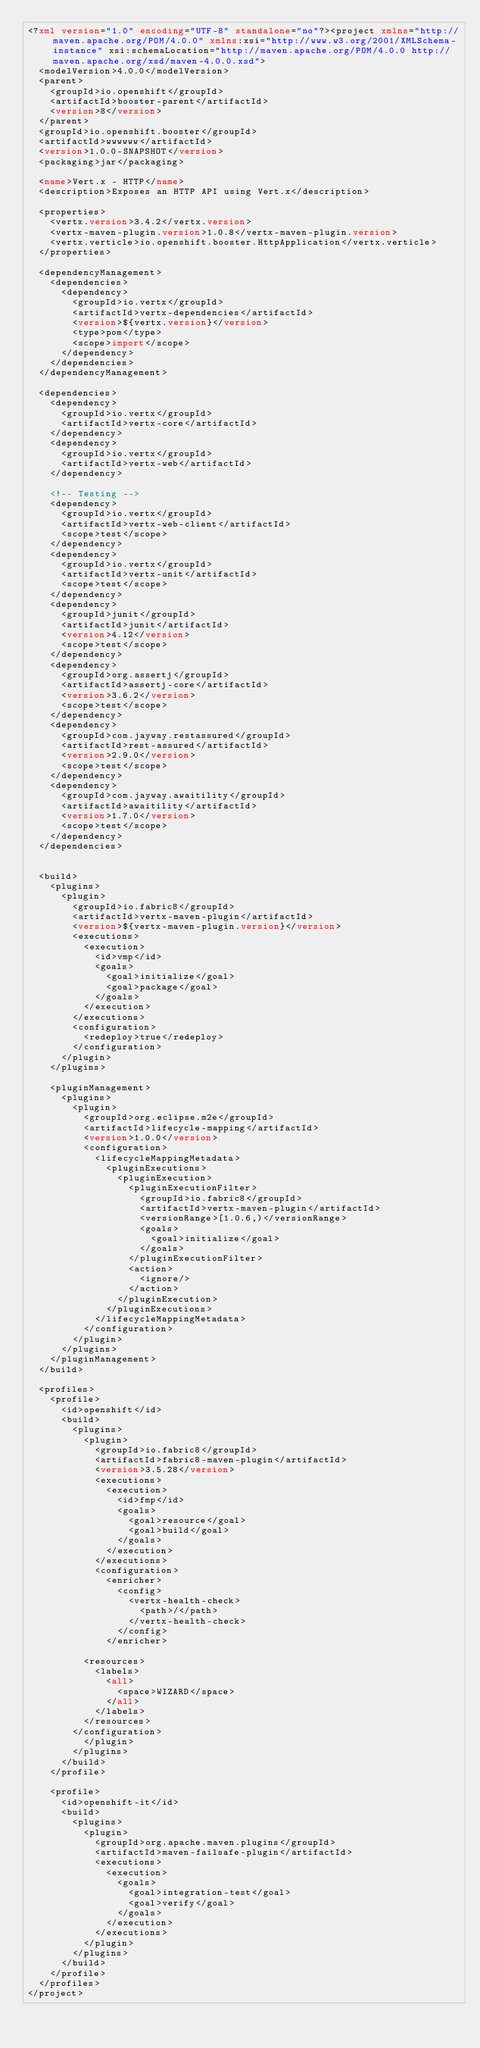Convert code to text. <code><loc_0><loc_0><loc_500><loc_500><_XML_><?xml version="1.0" encoding="UTF-8" standalone="no"?><project xmlns="http://maven.apache.org/POM/4.0.0" xmlns:xsi="http://www.w3.org/2001/XMLSchema-instance" xsi:schemaLocation="http://maven.apache.org/POM/4.0.0 http://maven.apache.org/xsd/maven-4.0.0.xsd">
  <modelVersion>4.0.0</modelVersion>
  <parent>
    <groupId>io.openshift</groupId>
    <artifactId>booster-parent</artifactId>
    <version>8</version>
  </parent>
  <groupId>io.openshift.booster</groupId>
  <artifactId>wwwwww</artifactId>
  <version>1.0.0-SNAPSHOT</version>
  <packaging>jar</packaging>

  <name>Vert.x - HTTP</name>
  <description>Exposes an HTTP API using Vert.x</description>

  <properties>
    <vertx.version>3.4.2</vertx.version>
    <vertx-maven-plugin.version>1.0.8</vertx-maven-plugin.version>
    <vertx.verticle>io.openshift.booster.HttpApplication</vertx.verticle>
  </properties>

  <dependencyManagement>
    <dependencies>
      <dependency>
        <groupId>io.vertx</groupId>
        <artifactId>vertx-dependencies</artifactId>
        <version>${vertx.version}</version>
        <type>pom</type>
        <scope>import</scope>
      </dependency>
    </dependencies>
  </dependencyManagement>

  <dependencies>
    <dependency>
      <groupId>io.vertx</groupId>
      <artifactId>vertx-core</artifactId>
    </dependency>
    <dependency>
      <groupId>io.vertx</groupId>
      <artifactId>vertx-web</artifactId>
    </dependency>

    <!-- Testing -->
    <dependency>
      <groupId>io.vertx</groupId>
      <artifactId>vertx-web-client</artifactId>
      <scope>test</scope>
    </dependency>
    <dependency>
      <groupId>io.vertx</groupId>
      <artifactId>vertx-unit</artifactId>
      <scope>test</scope>
    </dependency>
    <dependency>
      <groupId>junit</groupId>
      <artifactId>junit</artifactId>
      <version>4.12</version>
      <scope>test</scope>
    </dependency>
    <dependency>
      <groupId>org.assertj</groupId>
      <artifactId>assertj-core</artifactId>
      <version>3.6.2</version>
      <scope>test</scope>
    </dependency>
    <dependency>
      <groupId>com.jayway.restassured</groupId>
      <artifactId>rest-assured</artifactId>
      <version>2.9.0</version>
      <scope>test</scope>
    </dependency>
    <dependency>
      <groupId>com.jayway.awaitility</groupId>
      <artifactId>awaitility</artifactId>
      <version>1.7.0</version>
      <scope>test</scope>
    </dependency>
  </dependencies>


  <build>
    <plugins>
      <plugin>
        <groupId>io.fabric8</groupId>
        <artifactId>vertx-maven-plugin</artifactId>
        <version>${vertx-maven-plugin.version}</version>
        <executions>
          <execution>
            <id>vmp</id>
            <goals>
              <goal>initialize</goal>
              <goal>package</goal>
            </goals>
          </execution>
        </executions>
        <configuration>
          <redeploy>true</redeploy>
        </configuration>
      </plugin>
    </plugins>

    <pluginManagement>
      <plugins>
        <plugin>
          <groupId>org.eclipse.m2e</groupId>
          <artifactId>lifecycle-mapping</artifactId>
          <version>1.0.0</version>
          <configuration>
            <lifecycleMappingMetadata>
              <pluginExecutions>
                <pluginExecution>
                  <pluginExecutionFilter>
                    <groupId>io.fabric8</groupId>
                    <artifactId>vertx-maven-plugin</artifactId>
                    <versionRange>[1.0.6,)</versionRange>
                    <goals>
                      <goal>initialize</goal>
                    </goals>
                  </pluginExecutionFilter>
                  <action>
                    <ignore/>
                  </action>
                </pluginExecution>
              </pluginExecutions>
            </lifecycleMappingMetadata>
          </configuration>
        </plugin>
      </plugins>
    </pluginManagement>
  </build>

  <profiles>
    <profile>
      <id>openshift</id>
      <build>
        <plugins>
          <plugin>
            <groupId>io.fabric8</groupId>
            <artifactId>fabric8-maven-plugin</artifactId>
            <version>3.5.28</version>
            <executions>
              <execution>
                <id>fmp</id>
                <goals>
                  <goal>resource</goal>
                  <goal>build</goal>
                </goals>
              </execution>
            </executions>
            <configuration>
              <enricher>
                <config>
                  <vertx-health-check>
                    <path>/</path>
                  </vertx-health-check>
                </config>
              </enricher>
            
          <resources>
            <labels>
              <all>
                <space>WIZARD</space>
              </all>
            </labels>
          </resources>
        </configuration>
          </plugin>
        </plugins>
      </build>
    </profile>

    <profile>
      <id>openshift-it</id>
      <build>
        <plugins>
          <plugin>
            <groupId>org.apache.maven.plugins</groupId>
            <artifactId>maven-failsafe-plugin</artifactId>
            <executions>
              <execution>
                <goals>
                  <goal>integration-test</goal>
                  <goal>verify</goal>
                </goals>
              </execution>
            </executions>
          </plugin>
        </plugins>
      </build>
    </profile>
  </profiles>
</project></code> 